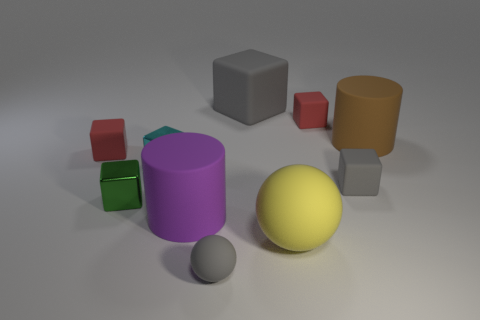Subtract all balls. How many objects are left? 8 Subtract 3 blocks. How many blocks are left? 3 Subtract all cyan blocks. Subtract all gray cylinders. How many blocks are left? 5 Subtract all yellow cylinders. How many green cubes are left? 1 Subtract all tiny gray matte balls. Subtract all purple cylinders. How many objects are left? 8 Add 4 red cubes. How many red cubes are left? 6 Add 6 small gray things. How many small gray things exist? 8 Subtract all brown cylinders. How many cylinders are left? 1 Subtract all big rubber blocks. How many blocks are left? 5 Subtract 1 green blocks. How many objects are left? 9 